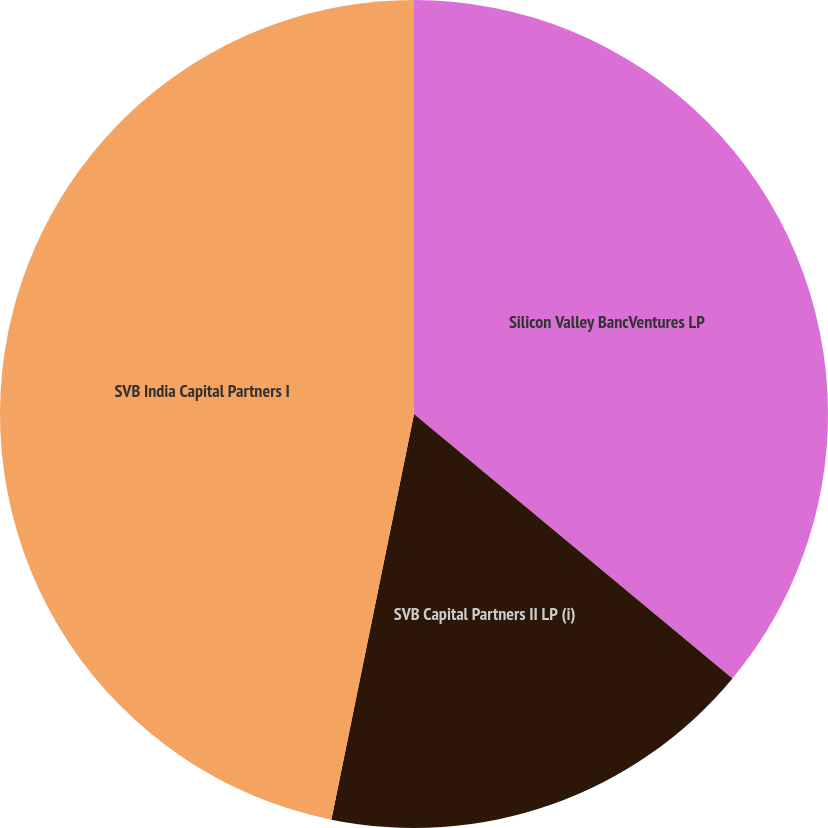Convert chart to OTSL. <chart><loc_0><loc_0><loc_500><loc_500><pie_chart><fcel>Silicon Valley BancVentures LP<fcel>SVB Capital Partners II LP (i)<fcel>SVB India Capital Partners I<nl><fcel>36.03%<fcel>17.17%<fcel>46.8%<nl></chart> 